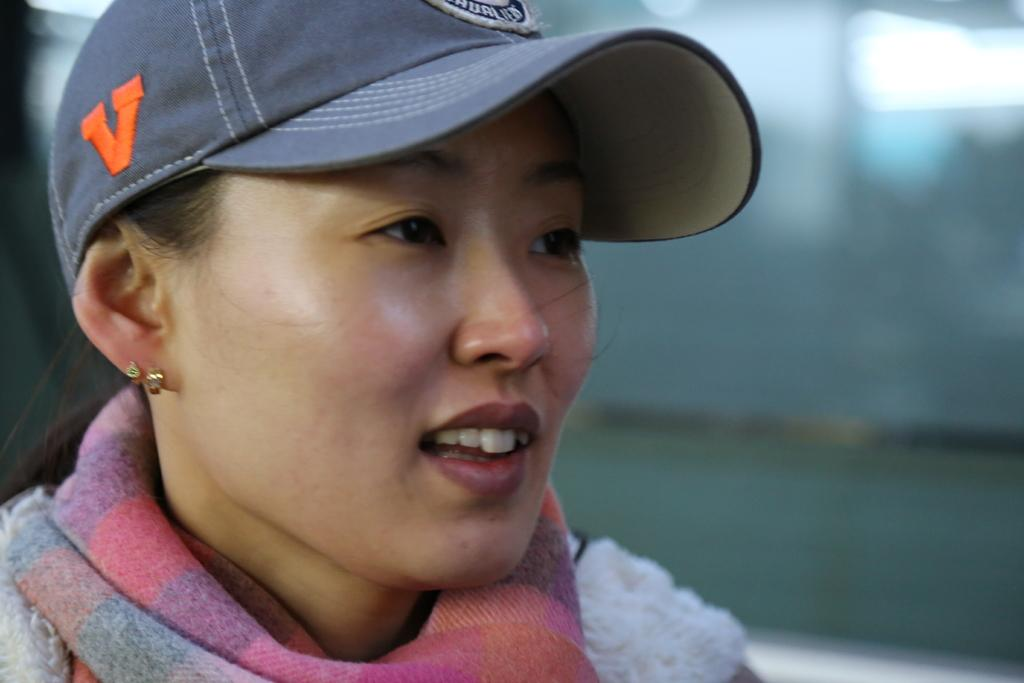Who is present in the image? There is a woman in the image. What is the woman wearing on her head? The woman is wearing a cap. What is the woman wearing around her neck? The woman is wearing a scarf. In which direction is the woman looking? The woman is looking towards her left side. How would you describe the background of the image? The background of the image is blurred. How many frogs can be seen in the woman's territory in the image? There are no frogs or territories mentioned in the image; it only features a woman wearing a cap and scarf. 